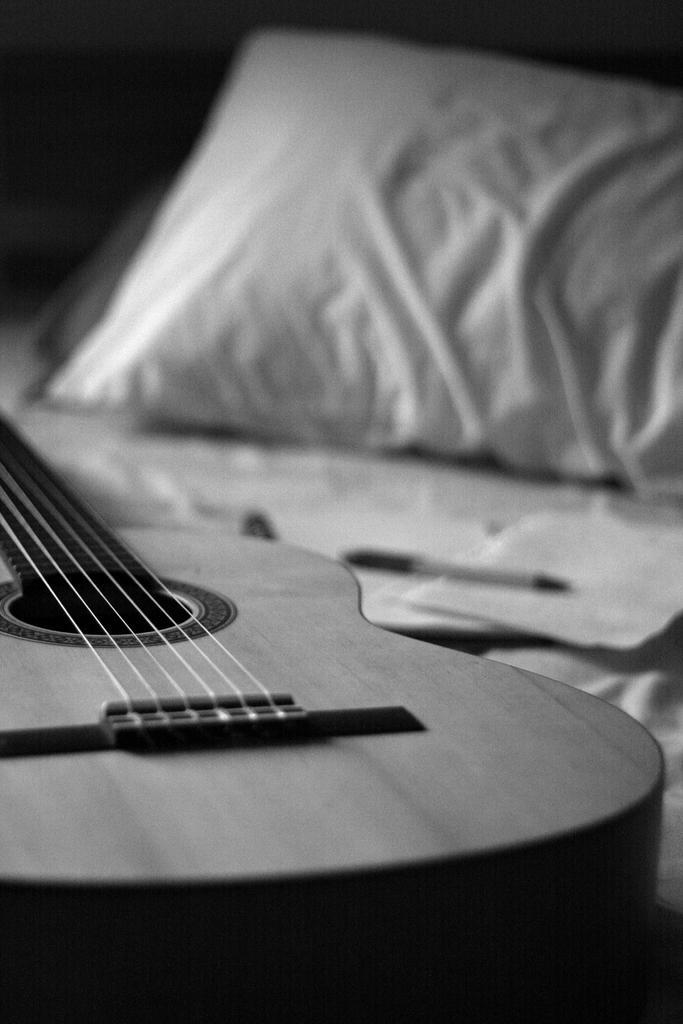Can you describe this image briefly? In this image i can see a guitar which is on the bed. 